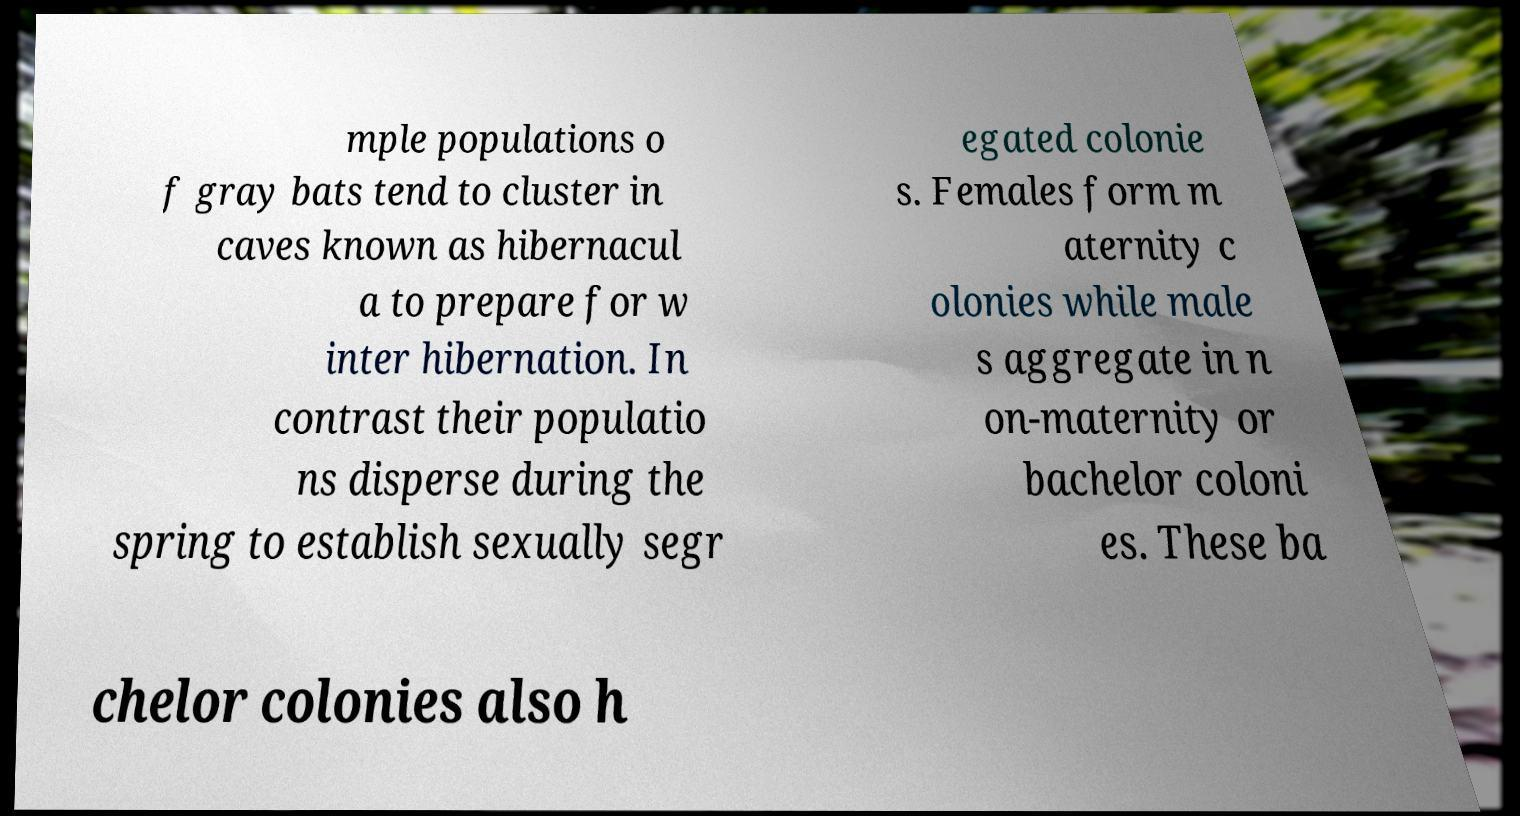What messages or text are displayed in this image? I need them in a readable, typed format. mple populations o f gray bats tend to cluster in caves known as hibernacul a to prepare for w inter hibernation. In contrast their populatio ns disperse during the spring to establish sexually segr egated colonie s. Females form m aternity c olonies while male s aggregate in n on-maternity or bachelor coloni es. These ba chelor colonies also h 